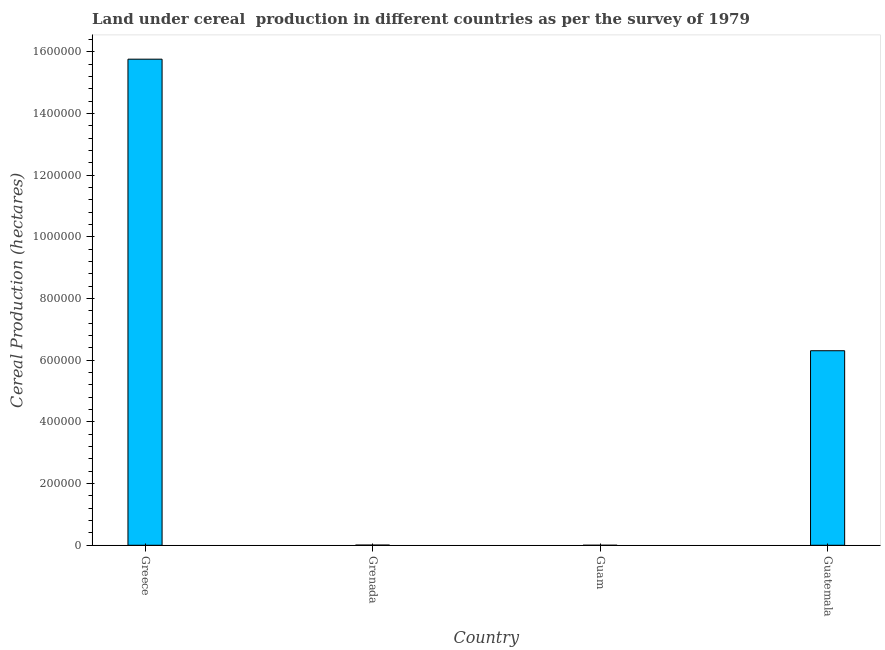Does the graph contain any zero values?
Your answer should be very brief. No. Does the graph contain grids?
Make the answer very short. No. What is the title of the graph?
Offer a terse response. Land under cereal  production in different countries as per the survey of 1979. What is the label or title of the X-axis?
Your answer should be very brief. Country. What is the label or title of the Y-axis?
Give a very brief answer. Cereal Production (hectares). What is the land under cereal production in Guatemala?
Offer a terse response. 6.31e+05. Across all countries, what is the maximum land under cereal production?
Provide a succinct answer. 1.58e+06. In which country was the land under cereal production minimum?
Your response must be concise. Guam. What is the sum of the land under cereal production?
Make the answer very short. 2.21e+06. What is the difference between the land under cereal production in Grenada and Guam?
Your answer should be very brief. 596. What is the average land under cereal production per country?
Provide a short and direct response. 5.52e+05. What is the median land under cereal production?
Give a very brief answer. 3.16e+05. In how many countries, is the land under cereal production greater than 600000 hectares?
Offer a very short reply. 2. What is the ratio of the land under cereal production in Greece to that in Grenada?
Your answer should be very brief. 2601.47. Is the difference between the land under cereal production in Grenada and Guatemala greater than the difference between any two countries?
Offer a terse response. No. What is the difference between the highest and the second highest land under cereal production?
Provide a short and direct response. 9.46e+05. Is the sum of the land under cereal production in Grenada and Guam greater than the maximum land under cereal production across all countries?
Offer a terse response. No. What is the difference between the highest and the lowest land under cereal production?
Give a very brief answer. 1.58e+06. Are all the bars in the graph horizontal?
Your answer should be compact. No. Are the values on the major ticks of Y-axis written in scientific E-notation?
Offer a terse response. No. What is the Cereal Production (hectares) of Greece?
Your answer should be very brief. 1.58e+06. What is the Cereal Production (hectares) in Grenada?
Offer a terse response. 606. What is the Cereal Production (hectares) of Guam?
Keep it short and to the point. 10. What is the Cereal Production (hectares) in Guatemala?
Provide a short and direct response. 6.31e+05. What is the difference between the Cereal Production (hectares) in Greece and Grenada?
Your answer should be compact. 1.58e+06. What is the difference between the Cereal Production (hectares) in Greece and Guam?
Your answer should be compact. 1.58e+06. What is the difference between the Cereal Production (hectares) in Greece and Guatemala?
Offer a terse response. 9.46e+05. What is the difference between the Cereal Production (hectares) in Grenada and Guam?
Your answer should be compact. 596. What is the difference between the Cereal Production (hectares) in Grenada and Guatemala?
Your answer should be compact. -6.30e+05. What is the difference between the Cereal Production (hectares) in Guam and Guatemala?
Ensure brevity in your answer.  -6.31e+05. What is the ratio of the Cereal Production (hectares) in Greece to that in Grenada?
Give a very brief answer. 2601.47. What is the ratio of the Cereal Production (hectares) in Greece to that in Guam?
Your answer should be compact. 1.58e+05. What is the ratio of the Cereal Production (hectares) in Greece to that in Guatemala?
Keep it short and to the point. 2.5. What is the ratio of the Cereal Production (hectares) in Grenada to that in Guam?
Keep it short and to the point. 60.6. 